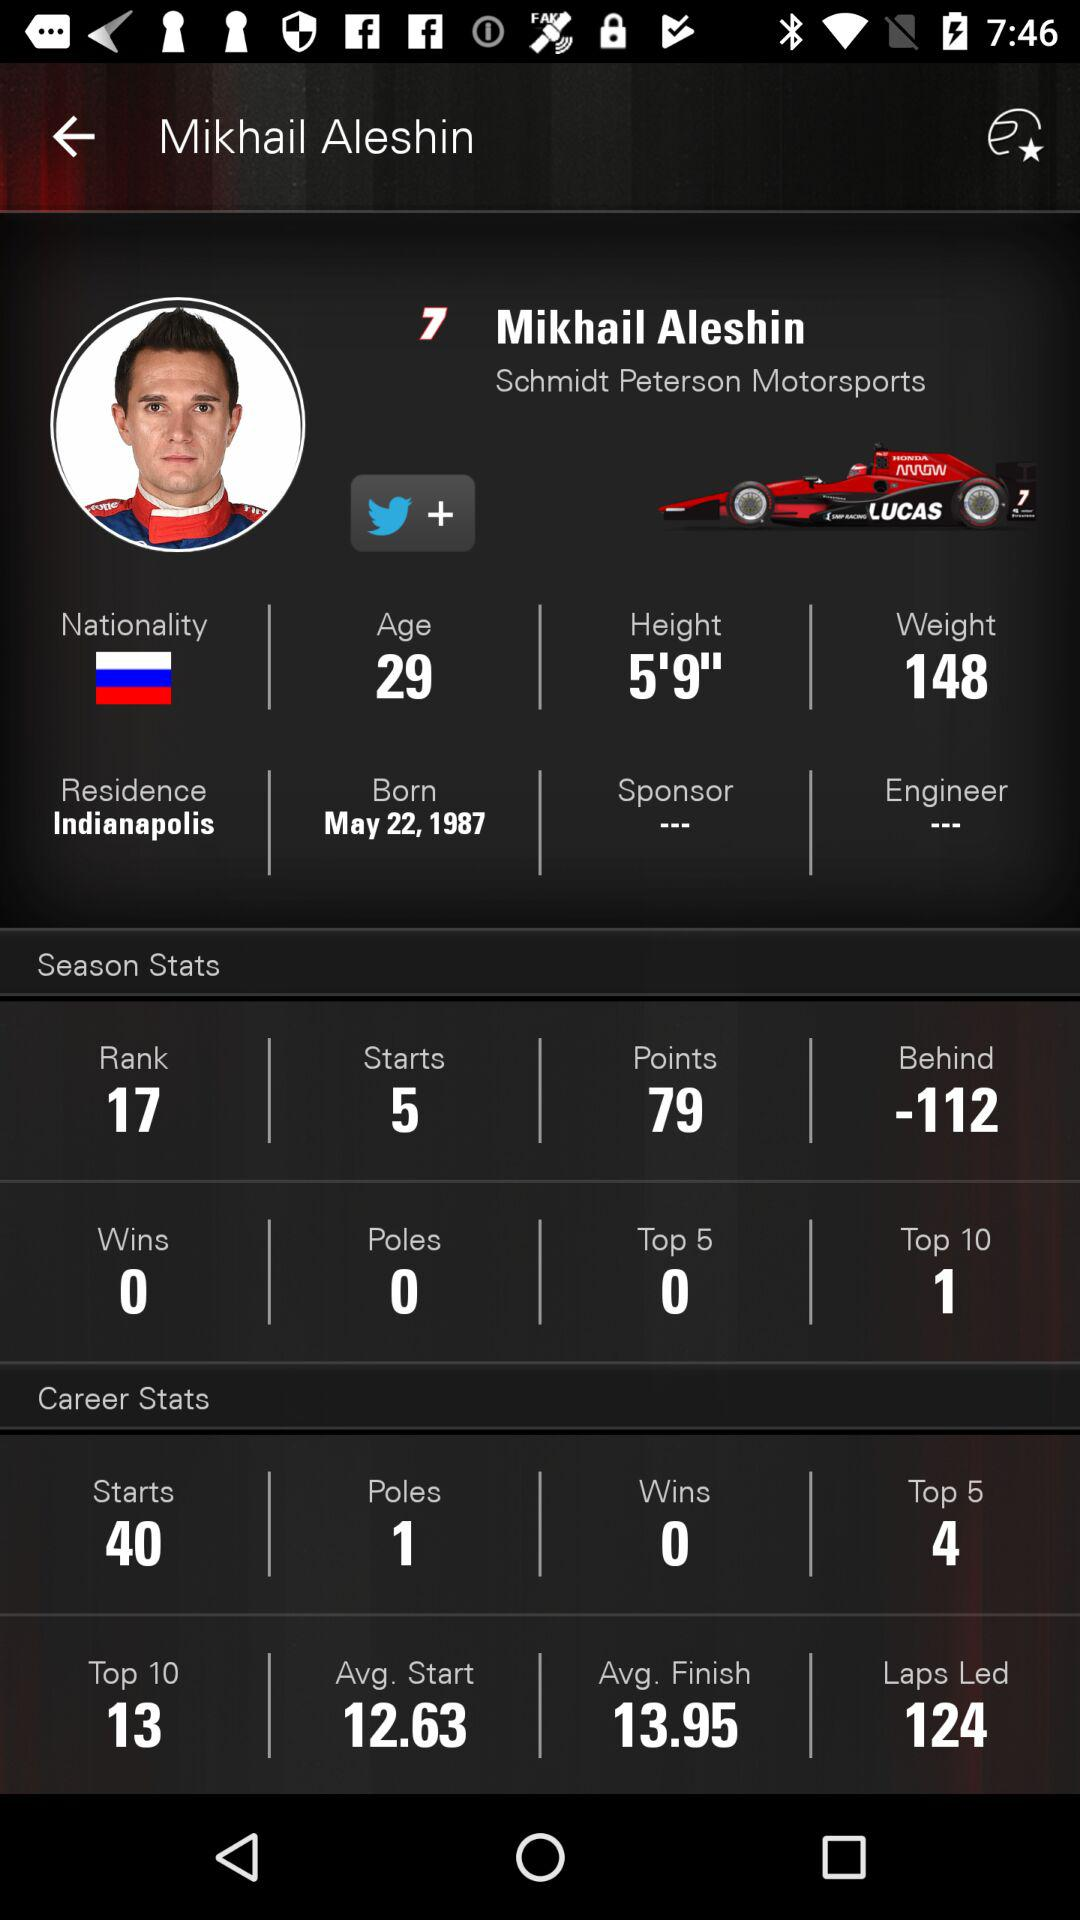What is the age of Mikhail Aleshin? The age of Mikhail Aleshin is 29 years. 